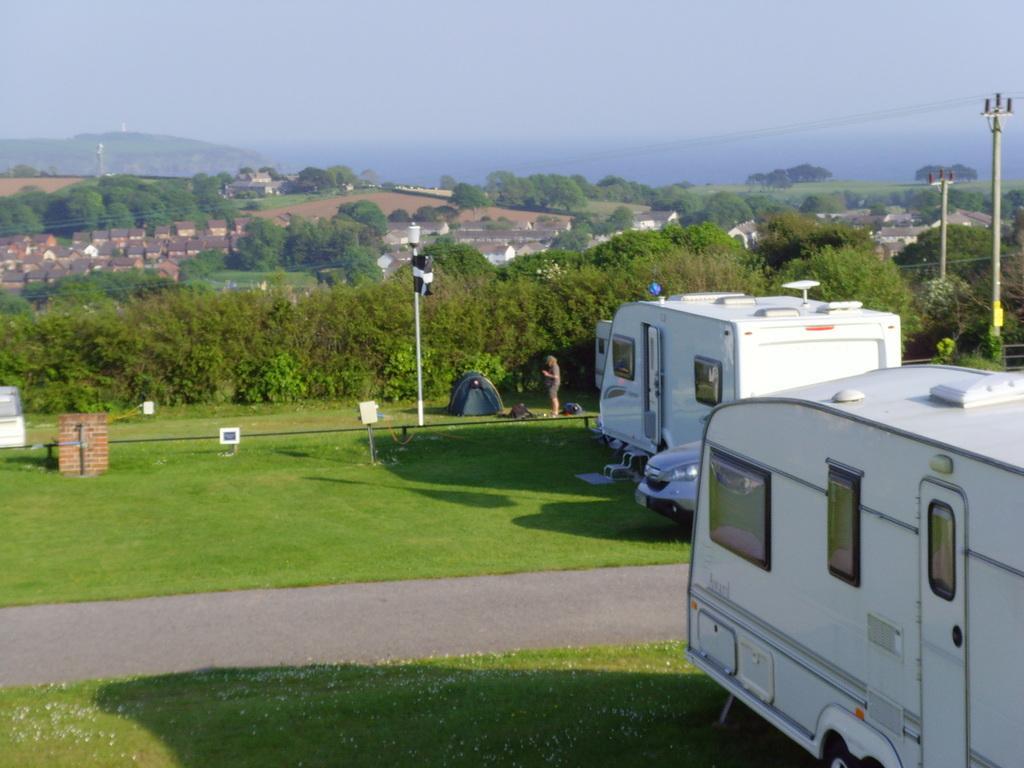How would you summarize this image in a sentence or two? In this image we can see a few vehicles, there are some plants, grass, trees, poles, lights, buildings, people and some other objects on the ground, in the background we can see the mountains and the sky. 